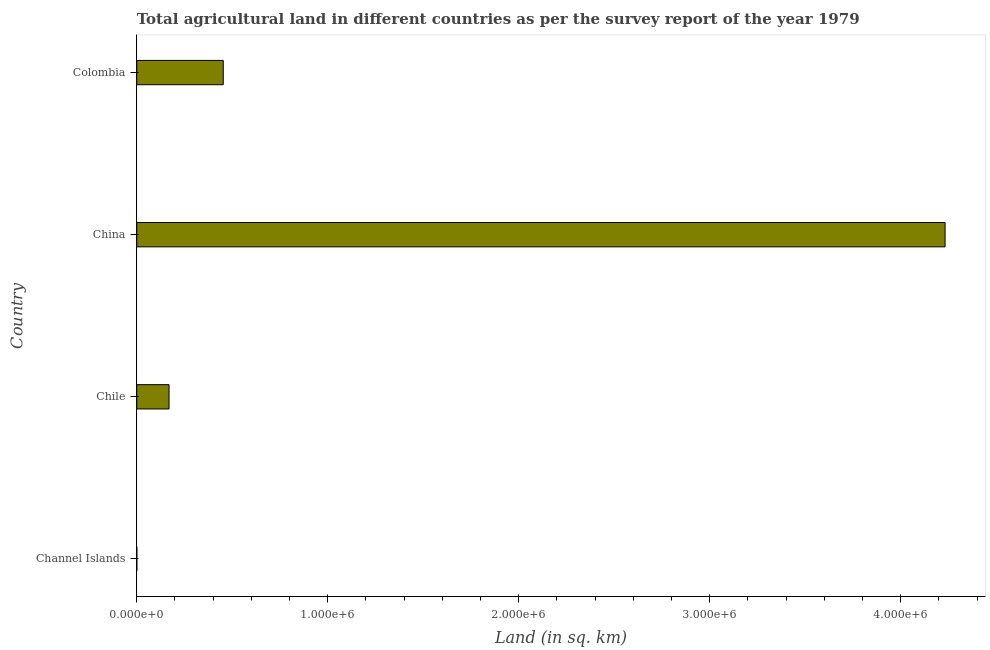Does the graph contain any zero values?
Your response must be concise. No. Does the graph contain grids?
Give a very brief answer. No. What is the title of the graph?
Give a very brief answer. Total agricultural land in different countries as per the survey report of the year 1979. What is the label or title of the X-axis?
Your answer should be very brief. Land (in sq. km). What is the label or title of the Y-axis?
Provide a succinct answer. Country. Across all countries, what is the maximum agricultural land?
Offer a very short reply. 4.23e+06. Across all countries, what is the minimum agricultural land?
Your response must be concise. 87. In which country was the agricultural land minimum?
Offer a very short reply. Channel Islands. What is the sum of the agricultural land?
Ensure brevity in your answer.  4.85e+06. What is the difference between the agricultural land in China and Colombia?
Your answer should be compact. 3.78e+06. What is the average agricultural land per country?
Your response must be concise. 1.21e+06. What is the median agricultural land?
Keep it short and to the point. 3.11e+05. What is the difference between the highest and the second highest agricultural land?
Provide a succinct answer. 3.78e+06. Is the sum of the agricultural land in Channel Islands and Chile greater than the maximum agricultural land across all countries?
Give a very brief answer. No. What is the difference between the highest and the lowest agricultural land?
Offer a very short reply. 4.23e+06. In how many countries, is the agricultural land greater than the average agricultural land taken over all countries?
Ensure brevity in your answer.  1. How many bars are there?
Your answer should be compact. 4. What is the Land (in sq. km) of Channel Islands?
Your response must be concise. 87. What is the Land (in sq. km) of Chile?
Provide a short and direct response. 1.69e+05. What is the Land (in sq. km) of China?
Keep it short and to the point. 4.23e+06. What is the Land (in sq. km) of Colombia?
Your answer should be very brief. 4.53e+05. What is the difference between the Land (in sq. km) in Channel Islands and Chile?
Make the answer very short. -1.69e+05. What is the difference between the Land (in sq. km) in Channel Islands and China?
Offer a very short reply. -4.23e+06. What is the difference between the Land (in sq. km) in Channel Islands and Colombia?
Offer a very short reply. -4.53e+05. What is the difference between the Land (in sq. km) in Chile and China?
Make the answer very short. -4.06e+06. What is the difference between the Land (in sq. km) in Chile and Colombia?
Make the answer very short. -2.84e+05. What is the difference between the Land (in sq. km) in China and Colombia?
Ensure brevity in your answer.  3.78e+06. What is the ratio of the Land (in sq. km) in Channel Islands to that in Chile?
Offer a very short reply. 0. What is the ratio of the Land (in sq. km) in Chile to that in China?
Make the answer very short. 0.04. What is the ratio of the Land (in sq. km) in Chile to that in Colombia?
Ensure brevity in your answer.  0.37. What is the ratio of the Land (in sq. km) in China to that in Colombia?
Keep it short and to the point. 9.35. 